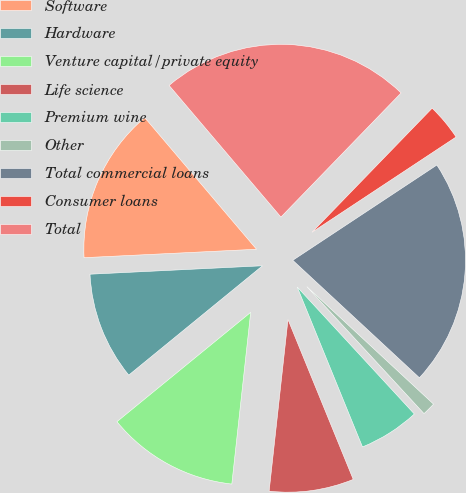Convert chart to OTSL. <chart><loc_0><loc_0><loc_500><loc_500><pie_chart><fcel>Software<fcel>Hardware<fcel>Venture capital/private equity<fcel>Life science<fcel>Premium wine<fcel>Other<fcel>Total commercial loans<fcel>Consumer loans<fcel>Total<nl><fcel>14.57%<fcel>10.13%<fcel>12.35%<fcel>7.91%<fcel>5.69%<fcel>1.24%<fcel>21.2%<fcel>3.46%<fcel>23.45%<nl></chart> 